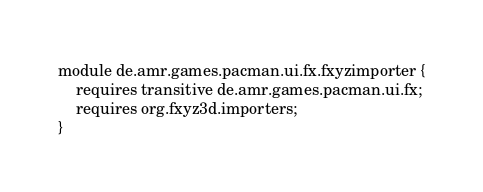Convert code to text. <code><loc_0><loc_0><loc_500><loc_500><_Java_>module de.amr.games.pacman.ui.fx.fxyzimporter {
	requires transitive de.amr.games.pacman.ui.fx;
	requires org.fxyz3d.importers;
}
</code> 